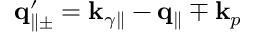<formula> <loc_0><loc_0><loc_500><loc_500>{ q } _ { \| \pm } ^ { \prime } = { k } _ { \gamma \| } - { q } _ { \| } \mp { k } _ { p }</formula> 